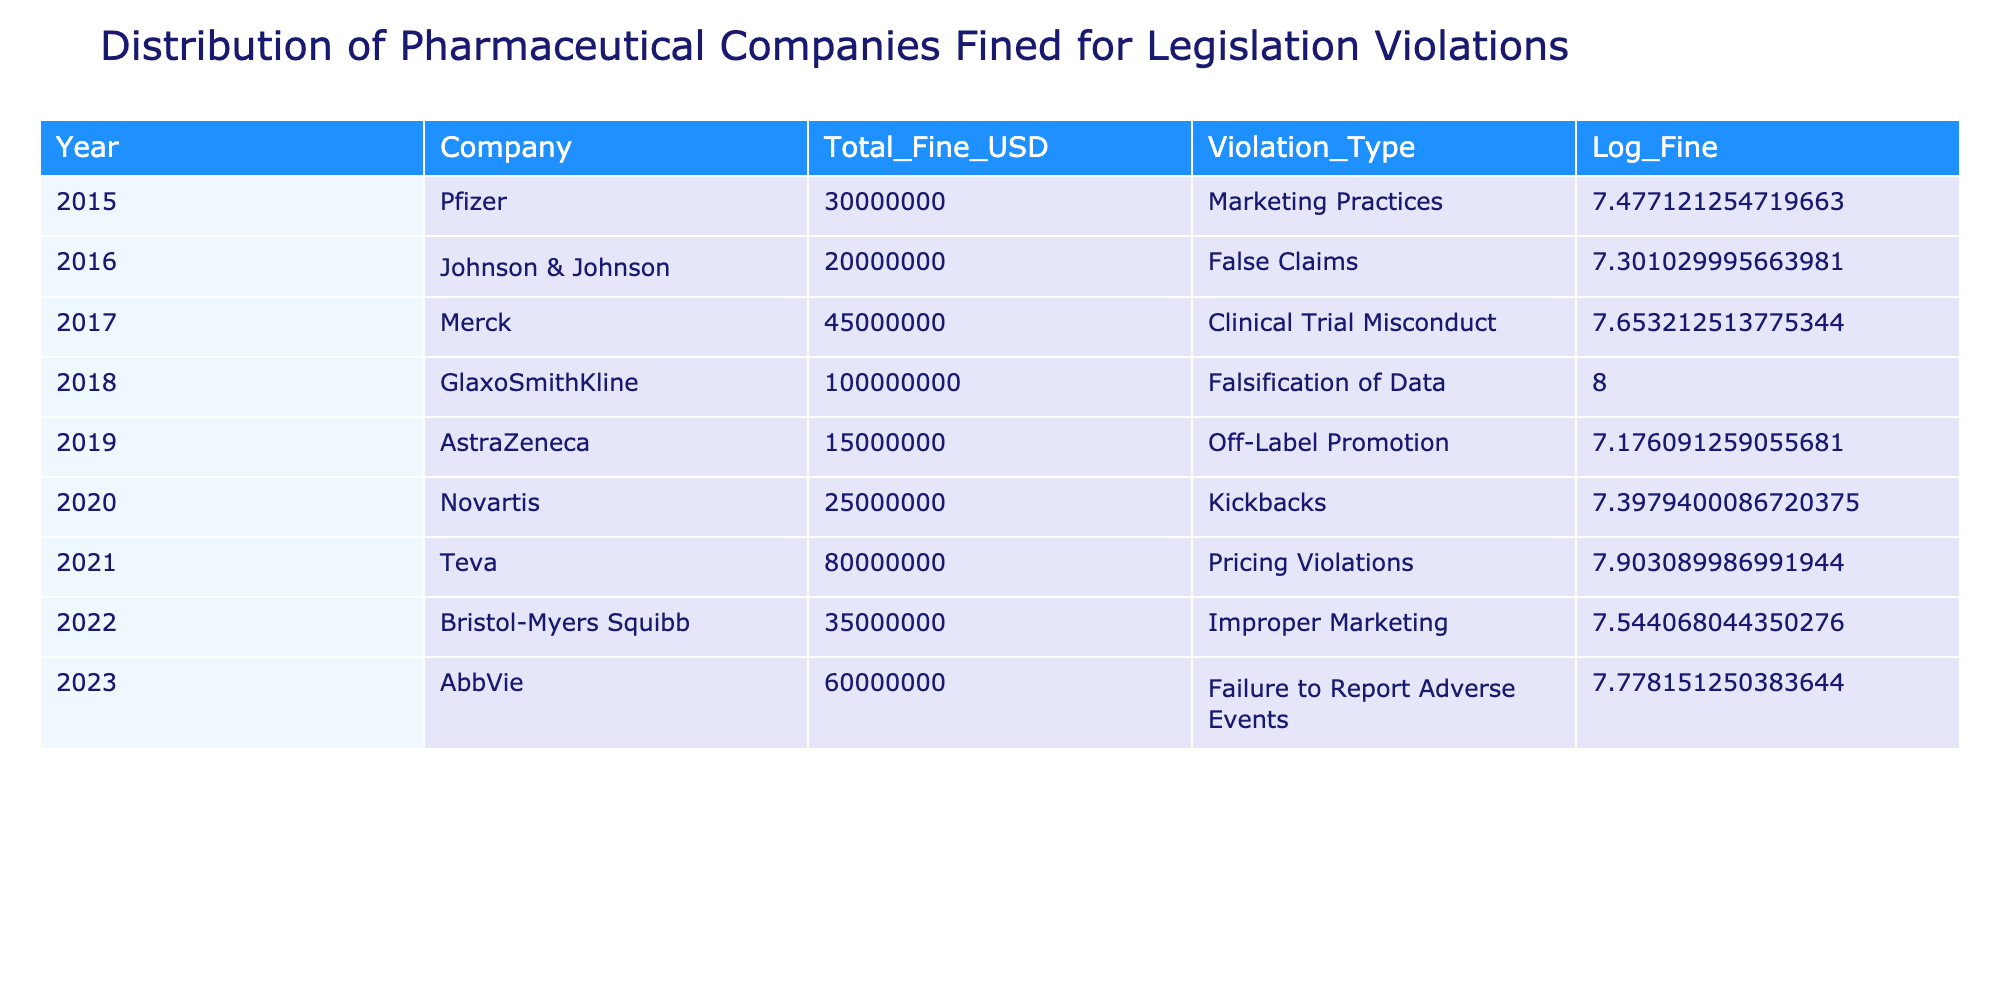What is the total fine amount for Merck in 2017? The table shows that Merck was fined a total of 45,000,000 USD in 2017. This value can be read directly from the respective cell in the table under the "Total_Fine_USD" column for the year 2017 and company Merck.
Answer: 45,000,000 USD Which company faced the highest fine and in which year? According to the table, GlaxoSmithKline faced the highest fine amount of 100,000,000 USD in the year 2018. This can be identified by scanning through the "Total_Fine_USD" column and determining the maximum value and its corresponding year.
Answer: GlaxoSmithKline, 2018 What is the average fine amount for the years 2015 to 2020? To calculate the average fine for these years, we first sum the fine amounts: 30,000,000 (2015) + 20,000,000 (2016) + 45,000,000 (2017) + 100,000,000 (2018) + 15,000,000 (2019) + 25,000,000 (2020) = 235,000,000 USD. Next, we divide this total by the number of years, which is 6, resulting in an average of 39,166,667 USD.
Answer: 39,166,667 USD Is there a company that has been fined for "False Claims"? The table indicates that Johnson & Johnson was fined for "False Claims" in 2016, providing a direct answer to the inquiry by confirming the presence of such a violation type in the dataset.
Answer: Yes Which year had the lowest fine and what was the violation type? The year with the lowest fine is 2019, where AstraZeneca was fined 15,000,000 USD for "Off-Label Promotion." This is found by examining the "Total_Fine_USD" column to identify the minimum value and correlating it with the corresponding violation type from the same row.
Answer: 2019, Off-Label Promotion How many companies were fined in total from 2020 to 2023? The companies fined in these years are Novartis (2020), Teva (2021), Bristol-Myers Squibb (2022), and AbbVie (2023), making it a total of four companies. This can be found by counting the distinct company entries associated with those years in the table.
Answer: 4 companies What is the difference in total fines between the highest and lowest fines in the table? The highest fine is 100,000,000 USD (GlaxoSmithKline in 2018), and the lowest fine is 15,000,000 USD (AstraZeneca in 2019). The difference is calculated as 100,000,000 - 15,000,000 = 85,000,000 USD. Thus, the absolute difference highlights the range of penalties.
Answer: 85,000,000 USD Did any company face penalties in multiple years? Looking through the data, each company listed only appears once in the table for a specific year. Hence, there are no companies that faced penalties in multiple years within this dataset.
Answer: No What percentage of the total fines were attributed to GlaxoSmithKline in 2018? First, we calculate the sum of all fines: 30000000 + 20000000 + 45000000 + 100000000 + 15000000 + 25000000 + 80000000 + 35000000 + 60000000 = 355000000 USD. Next, we see GlaxoSmithKline was fined 100,000,000 USD. The percentage is then (100,000,000 / 355,000,000) * 100, which equals approximately 28.17%.
Answer: 28.17% 